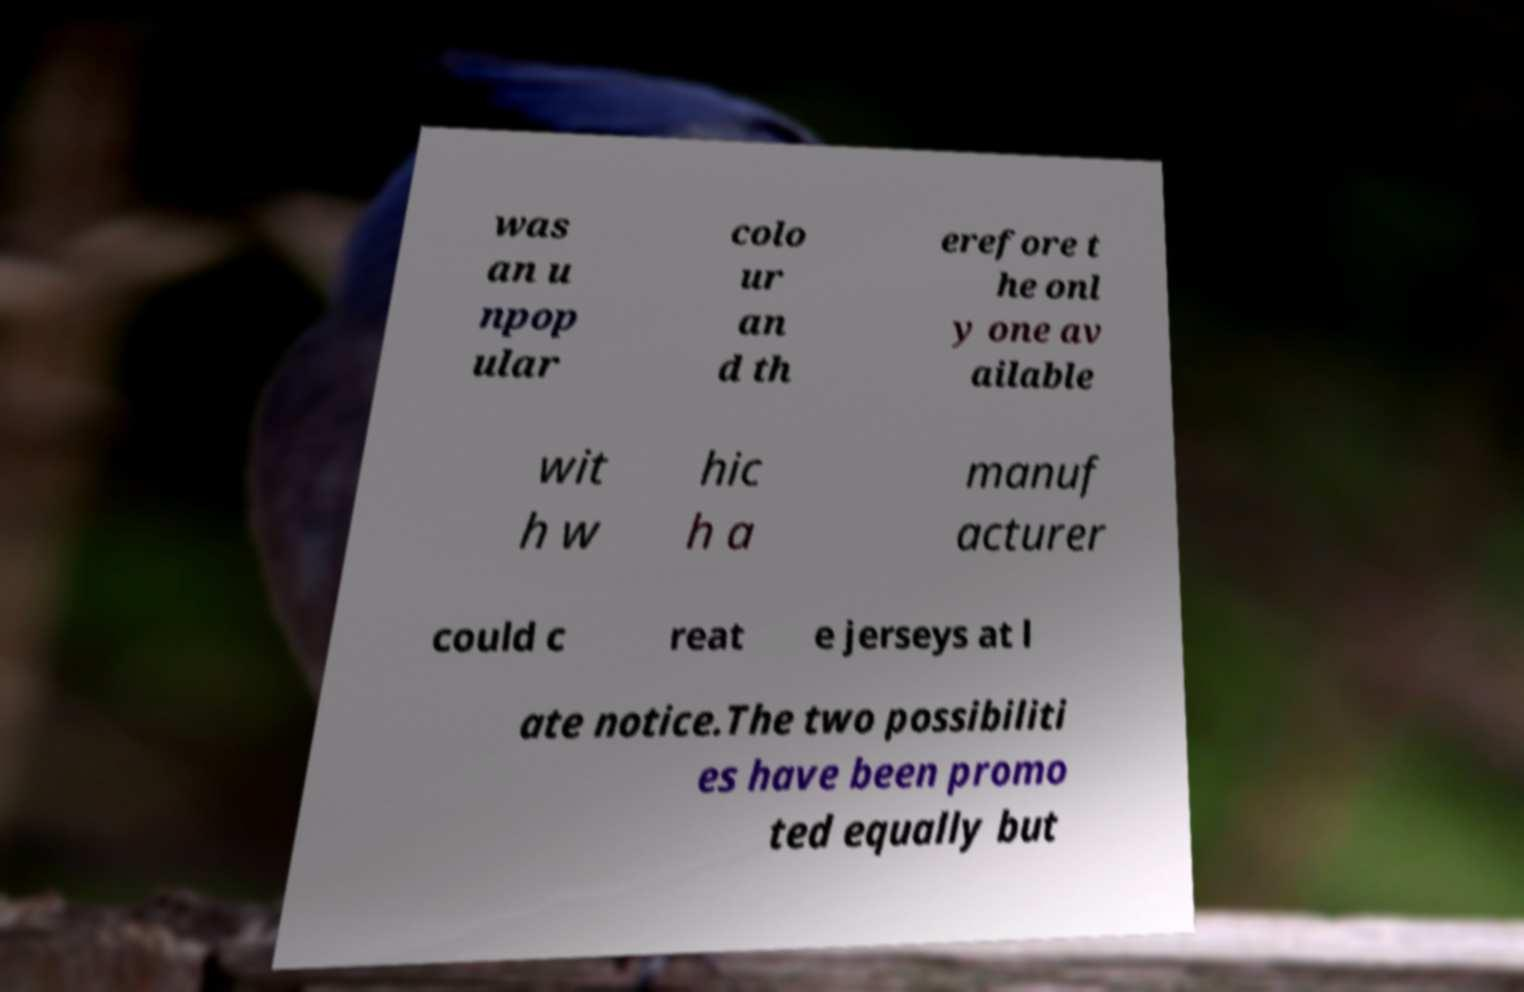Please read and relay the text visible in this image. What does it say? was an u npop ular colo ur an d th erefore t he onl y one av ailable wit h w hic h a manuf acturer could c reat e jerseys at l ate notice.The two possibiliti es have been promo ted equally but 